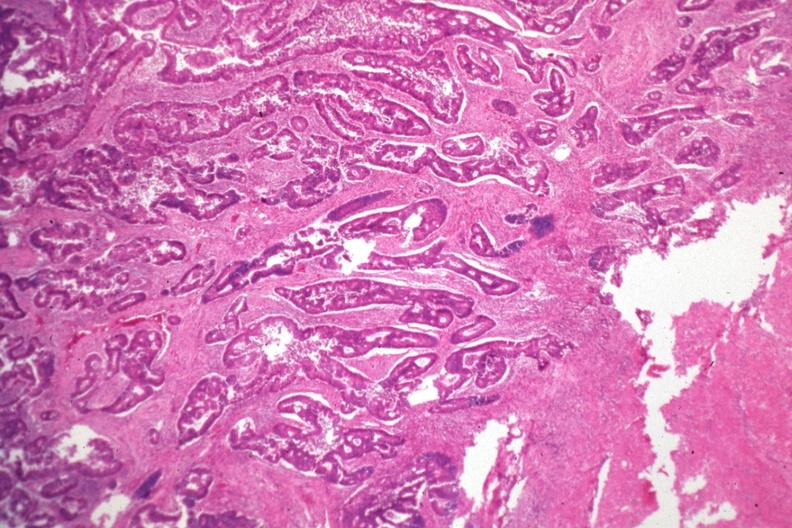s gastrointestinal present?
Answer the question using a single word or phrase. Yes 